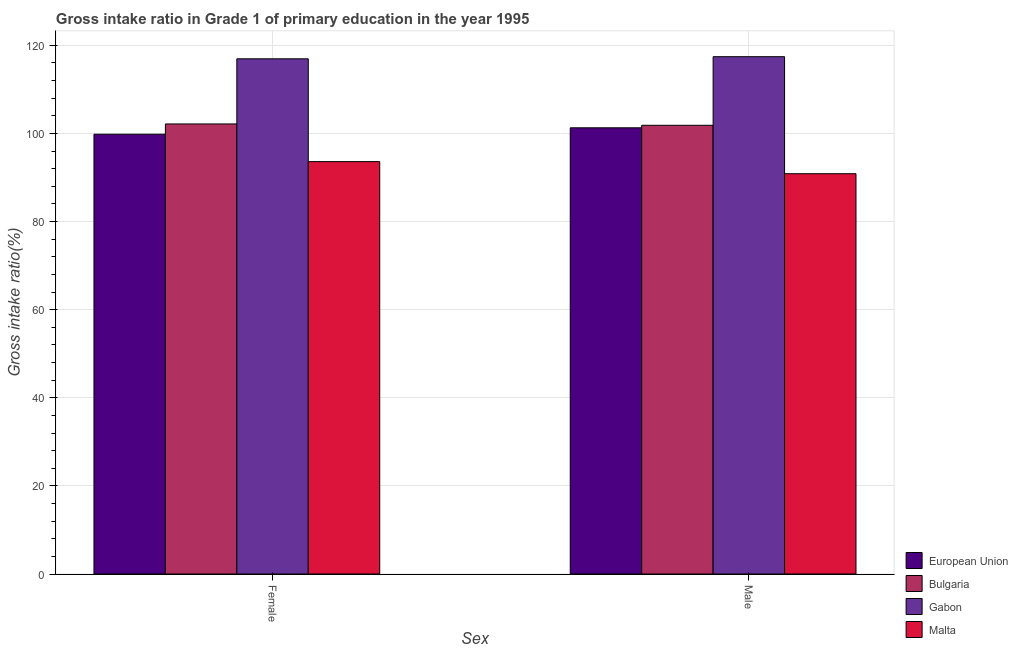How many groups of bars are there?
Provide a succinct answer. 2. Are the number of bars per tick equal to the number of legend labels?
Make the answer very short. Yes. How many bars are there on the 1st tick from the left?
Your answer should be compact. 4. How many bars are there on the 1st tick from the right?
Provide a short and direct response. 4. What is the gross intake ratio(female) in European Union?
Provide a succinct answer. 99.81. Across all countries, what is the maximum gross intake ratio(male)?
Your answer should be compact. 117.41. Across all countries, what is the minimum gross intake ratio(male)?
Keep it short and to the point. 90.85. In which country was the gross intake ratio(male) maximum?
Offer a terse response. Gabon. In which country was the gross intake ratio(male) minimum?
Keep it short and to the point. Malta. What is the total gross intake ratio(female) in the graph?
Keep it short and to the point. 412.48. What is the difference between the gross intake ratio(female) in European Union and that in Bulgaria?
Ensure brevity in your answer.  -2.33. What is the difference between the gross intake ratio(male) in Malta and the gross intake ratio(female) in Gabon?
Your answer should be compact. -26.08. What is the average gross intake ratio(female) per country?
Offer a very short reply. 103.12. What is the difference between the gross intake ratio(male) and gross intake ratio(female) in Malta?
Ensure brevity in your answer.  -2.75. In how many countries, is the gross intake ratio(female) greater than 16 %?
Your answer should be compact. 4. What is the ratio of the gross intake ratio(male) in Malta to that in European Union?
Offer a very short reply. 0.9. Is the gross intake ratio(male) in Gabon less than that in European Union?
Offer a terse response. No. In how many countries, is the gross intake ratio(female) greater than the average gross intake ratio(female) taken over all countries?
Offer a terse response. 1. What does the 4th bar from the left in Female represents?
Your answer should be compact. Malta. What does the 1st bar from the right in Female represents?
Provide a short and direct response. Malta. Are all the bars in the graph horizontal?
Make the answer very short. No. How many countries are there in the graph?
Offer a very short reply. 4. Does the graph contain any zero values?
Your answer should be compact. No. Does the graph contain grids?
Give a very brief answer. Yes. Where does the legend appear in the graph?
Your answer should be very brief. Bottom right. How are the legend labels stacked?
Your answer should be compact. Vertical. What is the title of the graph?
Ensure brevity in your answer.  Gross intake ratio in Grade 1 of primary education in the year 1995. What is the label or title of the X-axis?
Offer a terse response. Sex. What is the label or title of the Y-axis?
Provide a short and direct response. Gross intake ratio(%). What is the Gross intake ratio(%) in European Union in Female?
Give a very brief answer. 99.81. What is the Gross intake ratio(%) of Bulgaria in Female?
Ensure brevity in your answer.  102.14. What is the Gross intake ratio(%) of Gabon in Female?
Make the answer very short. 116.93. What is the Gross intake ratio(%) of Malta in Female?
Provide a short and direct response. 93.6. What is the Gross intake ratio(%) of European Union in Male?
Offer a very short reply. 101.27. What is the Gross intake ratio(%) in Bulgaria in Male?
Make the answer very short. 101.84. What is the Gross intake ratio(%) of Gabon in Male?
Keep it short and to the point. 117.41. What is the Gross intake ratio(%) in Malta in Male?
Ensure brevity in your answer.  90.85. Across all Sex, what is the maximum Gross intake ratio(%) of European Union?
Ensure brevity in your answer.  101.27. Across all Sex, what is the maximum Gross intake ratio(%) of Bulgaria?
Give a very brief answer. 102.14. Across all Sex, what is the maximum Gross intake ratio(%) in Gabon?
Keep it short and to the point. 117.41. Across all Sex, what is the maximum Gross intake ratio(%) in Malta?
Keep it short and to the point. 93.6. Across all Sex, what is the minimum Gross intake ratio(%) in European Union?
Give a very brief answer. 99.81. Across all Sex, what is the minimum Gross intake ratio(%) in Bulgaria?
Ensure brevity in your answer.  101.84. Across all Sex, what is the minimum Gross intake ratio(%) of Gabon?
Keep it short and to the point. 116.93. Across all Sex, what is the minimum Gross intake ratio(%) of Malta?
Your response must be concise. 90.85. What is the total Gross intake ratio(%) in European Union in the graph?
Give a very brief answer. 201.08. What is the total Gross intake ratio(%) of Bulgaria in the graph?
Your answer should be compact. 203.98. What is the total Gross intake ratio(%) of Gabon in the graph?
Make the answer very short. 234.34. What is the total Gross intake ratio(%) in Malta in the graph?
Your answer should be compact. 184.44. What is the difference between the Gross intake ratio(%) in European Union in Female and that in Male?
Your response must be concise. -1.45. What is the difference between the Gross intake ratio(%) in Bulgaria in Female and that in Male?
Provide a short and direct response. 0.3. What is the difference between the Gross intake ratio(%) in Gabon in Female and that in Male?
Provide a succinct answer. -0.48. What is the difference between the Gross intake ratio(%) in Malta in Female and that in Male?
Make the answer very short. 2.75. What is the difference between the Gross intake ratio(%) of European Union in Female and the Gross intake ratio(%) of Bulgaria in Male?
Make the answer very short. -2.03. What is the difference between the Gross intake ratio(%) in European Union in Female and the Gross intake ratio(%) in Gabon in Male?
Offer a terse response. -17.59. What is the difference between the Gross intake ratio(%) in European Union in Female and the Gross intake ratio(%) in Malta in Male?
Provide a succinct answer. 8.97. What is the difference between the Gross intake ratio(%) in Bulgaria in Female and the Gross intake ratio(%) in Gabon in Male?
Ensure brevity in your answer.  -15.27. What is the difference between the Gross intake ratio(%) of Bulgaria in Female and the Gross intake ratio(%) of Malta in Male?
Provide a short and direct response. 11.29. What is the difference between the Gross intake ratio(%) in Gabon in Female and the Gross intake ratio(%) in Malta in Male?
Give a very brief answer. 26.08. What is the average Gross intake ratio(%) in European Union per Sex?
Make the answer very short. 100.54. What is the average Gross intake ratio(%) of Bulgaria per Sex?
Your answer should be compact. 101.99. What is the average Gross intake ratio(%) in Gabon per Sex?
Offer a terse response. 117.17. What is the average Gross intake ratio(%) in Malta per Sex?
Provide a short and direct response. 92.22. What is the difference between the Gross intake ratio(%) in European Union and Gross intake ratio(%) in Bulgaria in Female?
Your answer should be compact. -2.33. What is the difference between the Gross intake ratio(%) in European Union and Gross intake ratio(%) in Gabon in Female?
Offer a very short reply. -17.11. What is the difference between the Gross intake ratio(%) in European Union and Gross intake ratio(%) in Malta in Female?
Your response must be concise. 6.22. What is the difference between the Gross intake ratio(%) in Bulgaria and Gross intake ratio(%) in Gabon in Female?
Provide a short and direct response. -14.79. What is the difference between the Gross intake ratio(%) in Bulgaria and Gross intake ratio(%) in Malta in Female?
Offer a terse response. 8.55. What is the difference between the Gross intake ratio(%) of Gabon and Gross intake ratio(%) of Malta in Female?
Keep it short and to the point. 23.33. What is the difference between the Gross intake ratio(%) in European Union and Gross intake ratio(%) in Bulgaria in Male?
Offer a terse response. -0.57. What is the difference between the Gross intake ratio(%) of European Union and Gross intake ratio(%) of Gabon in Male?
Your answer should be compact. -16.14. What is the difference between the Gross intake ratio(%) of European Union and Gross intake ratio(%) of Malta in Male?
Your response must be concise. 10.42. What is the difference between the Gross intake ratio(%) in Bulgaria and Gross intake ratio(%) in Gabon in Male?
Your answer should be very brief. -15.57. What is the difference between the Gross intake ratio(%) of Bulgaria and Gross intake ratio(%) of Malta in Male?
Provide a succinct answer. 10.99. What is the difference between the Gross intake ratio(%) of Gabon and Gross intake ratio(%) of Malta in Male?
Offer a very short reply. 26.56. What is the ratio of the Gross intake ratio(%) in European Union in Female to that in Male?
Offer a terse response. 0.99. What is the ratio of the Gross intake ratio(%) in Bulgaria in Female to that in Male?
Provide a short and direct response. 1. What is the ratio of the Gross intake ratio(%) of Gabon in Female to that in Male?
Your answer should be very brief. 1. What is the ratio of the Gross intake ratio(%) of Malta in Female to that in Male?
Offer a terse response. 1.03. What is the difference between the highest and the second highest Gross intake ratio(%) in European Union?
Your answer should be very brief. 1.45. What is the difference between the highest and the second highest Gross intake ratio(%) in Bulgaria?
Your response must be concise. 0.3. What is the difference between the highest and the second highest Gross intake ratio(%) of Gabon?
Give a very brief answer. 0.48. What is the difference between the highest and the second highest Gross intake ratio(%) of Malta?
Provide a short and direct response. 2.75. What is the difference between the highest and the lowest Gross intake ratio(%) in European Union?
Keep it short and to the point. 1.45. What is the difference between the highest and the lowest Gross intake ratio(%) in Bulgaria?
Give a very brief answer. 0.3. What is the difference between the highest and the lowest Gross intake ratio(%) of Gabon?
Your answer should be very brief. 0.48. What is the difference between the highest and the lowest Gross intake ratio(%) of Malta?
Ensure brevity in your answer.  2.75. 